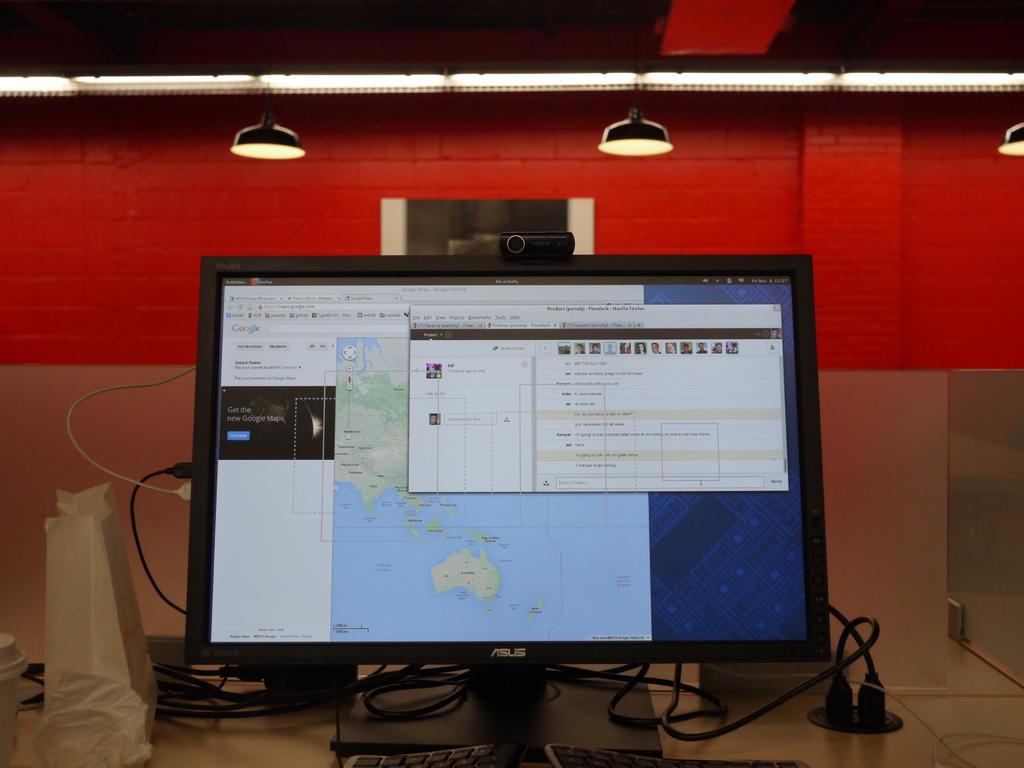What brand of monitor?
Your answer should be very brief. Asus. What is written on the left side of the map in black?
Offer a very short reply. Unanswerable. 